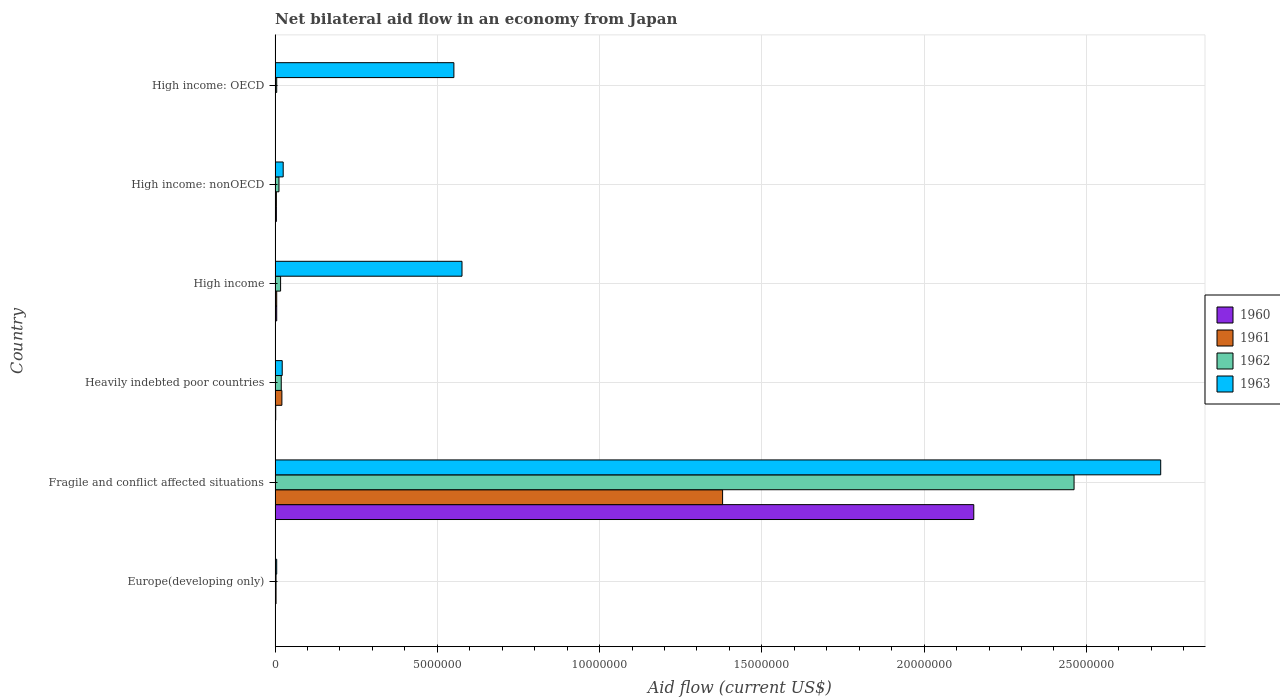How many groups of bars are there?
Provide a short and direct response. 6. Are the number of bars per tick equal to the number of legend labels?
Offer a very short reply. Yes. How many bars are there on the 2nd tick from the bottom?
Ensure brevity in your answer.  4. What is the label of the 6th group of bars from the top?
Provide a succinct answer. Europe(developing only). What is the net bilateral aid flow in 1963 in Fragile and conflict affected situations?
Your response must be concise. 2.73e+07. Across all countries, what is the maximum net bilateral aid flow in 1962?
Your answer should be compact. 2.46e+07. In which country was the net bilateral aid flow in 1963 maximum?
Offer a very short reply. Fragile and conflict affected situations. In which country was the net bilateral aid flow in 1962 minimum?
Keep it short and to the point. Europe(developing only). What is the total net bilateral aid flow in 1962 in the graph?
Offer a terse response. 2.52e+07. What is the difference between the net bilateral aid flow in 1961 in Europe(developing only) and that in High income?
Give a very brief answer. -2.00e+04. What is the difference between the net bilateral aid flow in 1963 in Heavily indebted poor countries and the net bilateral aid flow in 1961 in High income: OECD?
Ensure brevity in your answer.  2.10e+05. What is the average net bilateral aid flow in 1963 per country?
Make the answer very short. 6.51e+06. What is the ratio of the net bilateral aid flow in 1961 in Fragile and conflict affected situations to that in High income?
Offer a very short reply. 275.8. Is the net bilateral aid flow in 1962 in High income less than that in High income: nonOECD?
Offer a terse response. No. Is the difference between the net bilateral aid flow in 1961 in Fragile and conflict affected situations and Heavily indebted poor countries greater than the difference between the net bilateral aid flow in 1963 in Fragile and conflict affected situations and Heavily indebted poor countries?
Ensure brevity in your answer.  No. What is the difference between the highest and the second highest net bilateral aid flow in 1961?
Keep it short and to the point. 1.36e+07. What is the difference between the highest and the lowest net bilateral aid flow in 1961?
Provide a succinct answer. 1.38e+07. Is the sum of the net bilateral aid flow in 1962 in High income and High income: OECD greater than the maximum net bilateral aid flow in 1961 across all countries?
Offer a very short reply. No. What does the 4th bar from the top in High income: OECD represents?
Provide a short and direct response. 1960. What does the 4th bar from the bottom in Heavily indebted poor countries represents?
Make the answer very short. 1963. How many bars are there?
Give a very brief answer. 24. How many countries are there in the graph?
Your answer should be very brief. 6. What is the title of the graph?
Your answer should be very brief. Net bilateral aid flow in an economy from Japan. What is the label or title of the X-axis?
Your answer should be compact. Aid flow (current US$). What is the Aid flow (current US$) in 1961 in Europe(developing only)?
Give a very brief answer. 3.00e+04. What is the Aid flow (current US$) of 1962 in Europe(developing only)?
Ensure brevity in your answer.  3.00e+04. What is the Aid flow (current US$) in 1963 in Europe(developing only)?
Make the answer very short. 5.00e+04. What is the Aid flow (current US$) in 1960 in Fragile and conflict affected situations?
Offer a very short reply. 2.15e+07. What is the Aid flow (current US$) in 1961 in Fragile and conflict affected situations?
Keep it short and to the point. 1.38e+07. What is the Aid flow (current US$) in 1962 in Fragile and conflict affected situations?
Your response must be concise. 2.46e+07. What is the Aid flow (current US$) of 1963 in Fragile and conflict affected situations?
Provide a short and direct response. 2.73e+07. What is the Aid flow (current US$) of 1960 in Heavily indebted poor countries?
Provide a short and direct response. 2.00e+04. What is the Aid flow (current US$) in 1961 in Heavily indebted poor countries?
Ensure brevity in your answer.  2.10e+05. What is the Aid flow (current US$) in 1963 in Heavily indebted poor countries?
Ensure brevity in your answer.  2.20e+05. What is the Aid flow (current US$) in 1962 in High income?
Your answer should be very brief. 1.70e+05. What is the Aid flow (current US$) of 1963 in High income?
Your answer should be compact. 5.76e+06. What is the Aid flow (current US$) of 1962 in High income: nonOECD?
Ensure brevity in your answer.  1.20e+05. What is the Aid flow (current US$) in 1960 in High income: OECD?
Your answer should be compact. 10000. What is the Aid flow (current US$) in 1961 in High income: OECD?
Provide a short and direct response. 10000. What is the Aid flow (current US$) in 1963 in High income: OECD?
Your answer should be very brief. 5.51e+06. Across all countries, what is the maximum Aid flow (current US$) of 1960?
Ensure brevity in your answer.  2.15e+07. Across all countries, what is the maximum Aid flow (current US$) in 1961?
Offer a terse response. 1.38e+07. Across all countries, what is the maximum Aid flow (current US$) in 1962?
Your answer should be very brief. 2.46e+07. Across all countries, what is the maximum Aid flow (current US$) of 1963?
Ensure brevity in your answer.  2.73e+07. Across all countries, what is the minimum Aid flow (current US$) of 1960?
Your answer should be very brief. 10000. Across all countries, what is the minimum Aid flow (current US$) of 1961?
Offer a terse response. 10000. What is the total Aid flow (current US$) in 1960 in the graph?
Your response must be concise. 2.17e+07. What is the total Aid flow (current US$) of 1961 in the graph?
Provide a succinct answer. 1.41e+07. What is the total Aid flow (current US$) of 1962 in the graph?
Ensure brevity in your answer.  2.52e+07. What is the total Aid flow (current US$) in 1963 in the graph?
Keep it short and to the point. 3.91e+07. What is the difference between the Aid flow (current US$) in 1960 in Europe(developing only) and that in Fragile and conflict affected situations?
Offer a terse response. -2.15e+07. What is the difference between the Aid flow (current US$) in 1961 in Europe(developing only) and that in Fragile and conflict affected situations?
Make the answer very short. -1.38e+07. What is the difference between the Aid flow (current US$) in 1962 in Europe(developing only) and that in Fragile and conflict affected situations?
Keep it short and to the point. -2.46e+07. What is the difference between the Aid flow (current US$) of 1963 in Europe(developing only) and that in Fragile and conflict affected situations?
Make the answer very short. -2.72e+07. What is the difference between the Aid flow (current US$) in 1961 in Europe(developing only) and that in Heavily indebted poor countries?
Offer a terse response. -1.80e+05. What is the difference between the Aid flow (current US$) in 1960 in Europe(developing only) and that in High income?
Your answer should be compact. -4.00e+04. What is the difference between the Aid flow (current US$) of 1962 in Europe(developing only) and that in High income?
Provide a short and direct response. -1.40e+05. What is the difference between the Aid flow (current US$) of 1963 in Europe(developing only) and that in High income?
Your answer should be compact. -5.71e+06. What is the difference between the Aid flow (current US$) of 1961 in Europe(developing only) and that in High income: nonOECD?
Provide a short and direct response. -10000. What is the difference between the Aid flow (current US$) of 1963 in Europe(developing only) and that in High income: nonOECD?
Give a very brief answer. -2.00e+05. What is the difference between the Aid flow (current US$) in 1960 in Europe(developing only) and that in High income: OECD?
Provide a short and direct response. 0. What is the difference between the Aid flow (current US$) in 1963 in Europe(developing only) and that in High income: OECD?
Your answer should be compact. -5.46e+06. What is the difference between the Aid flow (current US$) in 1960 in Fragile and conflict affected situations and that in Heavily indebted poor countries?
Ensure brevity in your answer.  2.15e+07. What is the difference between the Aid flow (current US$) of 1961 in Fragile and conflict affected situations and that in Heavily indebted poor countries?
Give a very brief answer. 1.36e+07. What is the difference between the Aid flow (current US$) of 1962 in Fragile and conflict affected situations and that in Heavily indebted poor countries?
Offer a terse response. 2.44e+07. What is the difference between the Aid flow (current US$) in 1963 in Fragile and conflict affected situations and that in Heavily indebted poor countries?
Provide a short and direct response. 2.71e+07. What is the difference between the Aid flow (current US$) of 1960 in Fragile and conflict affected situations and that in High income?
Give a very brief answer. 2.15e+07. What is the difference between the Aid flow (current US$) of 1961 in Fragile and conflict affected situations and that in High income?
Your answer should be compact. 1.37e+07. What is the difference between the Aid flow (current US$) of 1962 in Fragile and conflict affected situations and that in High income?
Provide a succinct answer. 2.44e+07. What is the difference between the Aid flow (current US$) in 1963 in Fragile and conflict affected situations and that in High income?
Keep it short and to the point. 2.15e+07. What is the difference between the Aid flow (current US$) of 1960 in Fragile and conflict affected situations and that in High income: nonOECD?
Your answer should be very brief. 2.15e+07. What is the difference between the Aid flow (current US$) of 1961 in Fragile and conflict affected situations and that in High income: nonOECD?
Keep it short and to the point. 1.38e+07. What is the difference between the Aid flow (current US$) in 1962 in Fragile and conflict affected situations and that in High income: nonOECD?
Offer a terse response. 2.45e+07. What is the difference between the Aid flow (current US$) in 1963 in Fragile and conflict affected situations and that in High income: nonOECD?
Make the answer very short. 2.70e+07. What is the difference between the Aid flow (current US$) of 1960 in Fragile and conflict affected situations and that in High income: OECD?
Your answer should be very brief. 2.15e+07. What is the difference between the Aid flow (current US$) of 1961 in Fragile and conflict affected situations and that in High income: OECD?
Give a very brief answer. 1.38e+07. What is the difference between the Aid flow (current US$) in 1962 in Fragile and conflict affected situations and that in High income: OECD?
Your answer should be very brief. 2.46e+07. What is the difference between the Aid flow (current US$) of 1963 in Fragile and conflict affected situations and that in High income: OECD?
Keep it short and to the point. 2.18e+07. What is the difference between the Aid flow (current US$) of 1960 in Heavily indebted poor countries and that in High income?
Offer a terse response. -3.00e+04. What is the difference between the Aid flow (current US$) in 1961 in Heavily indebted poor countries and that in High income?
Your answer should be compact. 1.60e+05. What is the difference between the Aid flow (current US$) in 1963 in Heavily indebted poor countries and that in High income?
Make the answer very short. -5.54e+06. What is the difference between the Aid flow (current US$) in 1962 in Heavily indebted poor countries and that in High income: nonOECD?
Offer a very short reply. 7.00e+04. What is the difference between the Aid flow (current US$) in 1963 in Heavily indebted poor countries and that in High income: OECD?
Your answer should be very brief. -5.29e+06. What is the difference between the Aid flow (current US$) in 1962 in High income and that in High income: nonOECD?
Your answer should be very brief. 5.00e+04. What is the difference between the Aid flow (current US$) of 1963 in High income and that in High income: nonOECD?
Make the answer very short. 5.51e+06. What is the difference between the Aid flow (current US$) in 1961 in High income and that in High income: OECD?
Provide a succinct answer. 4.00e+04. What is the difference between the Aid flow (current US$) in 1962 in High income and that in High income: OECD?
Your answer should be compact. 1.20e+05. What is the difference between the Aid flow (current US$) of 1963 in High income and that in High income: OECD?
Ensure brevity in your answer.  2.50e+05. What is the difference between the Aid flow (current US$) in 1960 in High income: nonOECD and that in High income: OECD?
Provide a succinct answer. 3.00e+04. What is the difference between the Aid flow (current US$) in 1961 in High income: nonOECD and that in High income: OECD?
Your answer should be very brief. 3.00e+04. What is the difference between the Aid flow (current US$) in 1962 in High income: nonOECD and that in High income: OECD?
Offer a terse response. 7.00e+04. What is the difference between the Aid flow (current US$) in 1963 in High income: nonOECD and that in High income: OECD?
Your answer should be very brief. -5.26e+06. What is the difference between the Aid flow (current US$) of 1960 in Europe(developing only) and the Aid flow (current US$) of 1961 in Fragile and conflict affected situations?
Make the answer very short. -1.38e+07. What is the difference between the Aid flow (current US$) of 1960 in Europe(developing only) and the Aid flow (current US$) of 1962 in Fragile and conflict affected situations?
Give a very brief answer. -2.46e+07. What is the difference between the Aid flow (current US$) in 1960 in Europe(developing only) and the Aid flow (current US$) in 1963 in Fragile and conflict affected situations?
Ensure brevity in your answer.  -2.73e+07. What is the difference between the Aid flow (current US$) in 1961 in Europe(developing only) and the Aid flow (current US$) in 1962 in Fragile and conflict affected situations?
Your answer should be very brief. -2.46e+07. What is the difference between the Aid flow (current US$) in 1961 in Europe(developing only) and the Aid flow (current US$) in 1963 in Fragile and conflict affected situations?
Make the answer very short. -2.73e+07. What is the difference between the Aid flow (current US$) in 1962 in Europe(developing only) and the Aid flow (current US$) in 1963 in Fragile and conflict affected situations?
Ensure brevity in your answer.  -2.73e+07. What is the difference between the Aid flow (current US$) of 1960 in Europe(developing only) and the Aid flow (current US$) of 1961 in Heavily indebted poor countries?
Ensure brevity in your answer.  -2.00e+05. What is the difference between the Aid flow (current US$) of 1960 in Europe(developing only) and the Aid flow (current US$) of 1962 in Heavily indebted poor countries?
Make the answer very short. -1.80e+05. What is the difference between the Aid flow (current US$) in 1960 in Europe(developing only) and the Aid flow (current US$) in 1963 in Heavily indebted poor countries?
Provide a short and direct response. -2.10e+05. What is the difference between the Aid flow (current US$) of 1961 in Europe(developing only) and the Aid flow (current US$) of 1962 in Heavily indebted poor countries?
Ensure brevity in your answer.  -1.60e+05. What is the difference between the Aid flow (current US$) of 1960 in Europe(developing only) and the Aid flow (current US$) of 1961 in High income?
Your answer should be compact. -4.00e+04. What is the difference between the Aid flow (current US$) in 1960 in Europe(developing only) and the Aid flow (current US$) in 1963 in High income?
Keep it short and to the point. -5.75e+06. What is the difference between the Aid flow (current US$) in 1961 in Europe(developing only) and the Aid flow (current US$) in 1962 in High income?
Your answer should be very brief. -1.40e+05. What is the difference between the Aid flow (current US$) in 1961 in Europe(developing only) and the Aid flow (current US$) in 1963 in High income?
Offer a terse response. -5.73e+06. What is the difference between the Aid flow (current US$) in 1962 in Europe(developing only) and the Aid flow (current US$) in 1963 in High income?
Offer a terse response. -5.73e+06. What is the difference between the Aid flow (current US$) of 1960 in Europe(developing only) and the Aid flow (current US$) of 1962 in High income: nonOECD?
Make the answer very short. -1.10e+05. What is the difference between the Aid flow (current US$) of 1960 in Europe(developing only) and the Aid flow (current US$) of 1963 in High income: nonOECD?
Offer a terse response. -2.40e+05. What is the difference between the Aid flow (current US$) in 1961 in Europe(developing only) and the Aid flow (current US$) in 1963 in High income: nonOECD?
Provide a succinct answer. -2.20e+05. What is the difference between the Aid flow (current US$) of 1960 in Europe(developing only) and the Aid flow (current US$) of 1963 in High income: OECD?
Provide a short and direct response. -5.50e+06. What is the difference between the Aid flow (current US$) in 1961 in Europe(developing only) and the Aid flow (current US$) in 1963 in High income: OECD?
Make the answer very short. -5.48e+06. What is the difference between the Aid flow (current US$) in 1962 in Europe(developing only) and the Aid flow (current US$) in 1963 in High income: OECD?
Ensure brevity in your answer.  -5.48e+06. What is the difference between the Aid flow (current US$) of 1960 in Fragile and conflict affected situations and the Aid flow (current US$) of 1961 in Heavily indebted poor countries?
Make the answer very short. 2.13e+07. What is the difference between the Aid flow (current US$) of 1960 in Fragile and conflict affected situations and the Aid flow (current US$) of 1962 in Heavily indebted poor countries?
Your response must be concise. 2.13e+07. What is the difference between the Aid flow (current US$) in 1960 in Fragile and conflict affected situations and the Aid flow (current US$) in 1963 in Heavily indebted poor countries?
Offer a very short reply. 2.13e+07. What is the difference between the Aid flow (current US$) of 1961 in Fragile and conflict affected situations and the Aid flow (current US$) of 1962 in Heavily indebted poor countries?
Make the answer very short. 1.36e+07. What is the difference between the Aid flow (current US$) in 1961 in Fragile and conflict affected situations and the Aid flow (current US$) in 1963 in Heavily indebted poor countries?
Ensure brevity in your answer.  1.36e+07. What is the difference between the Aid flow (current US$) in 1962 in Fragile and conflict affected situations and the Aid flow (current US$) in 1963 in Heavily indebted poor countries?
Make the answer very short. 2.44e+07. What is the difference between the Aid flow (current US$) of 1960 in Fragile and conflict affected situations and the Aid flow (current US$) of 1961 in High income?
Ensure brevity in your answer.  2.15e+07. What is the difference between the Aid flow (current US$) of 1960 in Fragile and conflict affected situations and the Aid flow (current US$) of 1962 in High income?
Offer a terse response. 2.14e+07. What is the difference between the Aid flow (current US$) in 1960 in Fragile and conflict affected situations and the Aid flow (current US$) in 1963 in High income?
Your response must be concise. 1.58e+07. What is the difference between the Aid flow (current US$) of 1961 in Fragile and conflict affected situations and the Aid flow (current US$) of 1962 in High income?
Your answer should be compact. 1.36e+07. What is the difference between the Aid flow (current US$) of 1961 in Fragile and conflict affected situations and the Aid flow (current US$) of 1963 in High income?
Your response must be concise. 8.03e+06. What is the difference between the Aid flow (current US$) of 1962 in Fragile and conflict affected situations and the Aid flow (current US$) of 1963 in High income?
Provide a succinct answer. 1.89e+07. What is the difference between the Aid flow (current US$) in 1960 in Fragile and conflict affected situations and the Aid flow (current US$) in 1961 in High income: nonOECD?
Your answer should be very brief. 2.15e+07. What is the difference between the Aid flow (current US$) in 1960 in Fragile and conflict affected situations and the Aid flow (current US$) in 1962 in High income: nonOECD?
Your answer should be compact. 2.14e+07. What is the difference between the Aid flow (current US$) in 1960 in Fragile and conflict affected situations and the Aid flow (current US$) in 1963 in High income: nonOECD?
Your response must be concise. 2.13e+07. What is the difference between the Aid flow (current US$) of 1961 in Fragile and conflict affected situations and the Aid flow (current US$) of 1962 in High income: nonOECD?
Ensure brevity in your answer.  1.37e+07. What is the difference between the Aid flow (current US$) of 1961 in Fragile and conflict affected situations and the Aid flow (current US$) of 1963 in High income: nonOECD?
Your answer should be compact. 1.35e+07. What is the difference between the Aid flow (current US$) of 1962 in Fragile and conflict affected situations and the Aid flow (current US$) of 1963 in High income: nonOECD?
Provide a succinct answer. 2.44e+07. What is the difference between the Aid flow (current US$) in 1960 in Fragile and conflict affected situations and the Aid flow (current US$) in 1961 in High income: OECD?
Offer a very short reply. 2.15e+07. What is the difference between the Aid flow (current US$) of 1960 in Fragile and conflict affected situations and the Aid flow (current US$) of 1962 in High income: OECD?
Your answer should be compact. 2.15e+07. What is the difference between the Aid flow (current US$) of 1960 in Fragile and conflict affected situations and the Aid flow (current US$) of 1963 in High income: OECD?
Provide a short and direct response. 1.60e+07. What is the difference between the Aid flow (current US$) in 1961 in Fragile and conflict affected situations and the Aid flow (current US$) in 1962 in High income: OECD?
Make the answer very short. 1.37e+07. What is the difference between the Aid flow (current US$) in 1961 in Fragile and conflict affected situations and the Aid flow (current US$) in 1963 in High income: OECD?
Ensure brevity in your answer.  8.28e+06. What is the difference between the Aid flow (current US$) of 1962 in Fragile and conflict affected situations and the Aid flow (current US$) of 1963 in High income: OECD?
Keep it short and to the point. 1.91e+07. What is the difference between the Aid flow (current US$) in 1960 in Heavily indebted poor countries and the Aid flow (current US$) in 1961 in High income?
Provide a succinct answer. -3.00e+04. What is the difference between the Aid flow (current US$) in 1960 in Heavily indebted poor countries and the Aid flow (current US$) in 1962 in High income?
Provide a succinct answer. -1.50e+05. What is the difference between the Aid flow (current US$) of 1960 in Heavily indebted poor countries and the Aid flow (current US$) of 1963 in High income?
Make the answer very short. -5.74e+06. What is the difference between the Aid flow (current US$) of 1961 in Heavily indebted poor countries and the Aid flow (current US$) of 1963 in High income?
Your answer should be compact. -5.55e+06. What is the difference between the Aid flow (current US$) of 1962 in Heavily indebted poor countries and the Aid flow (current US$) of 1963 in High income?
Ensure brevity in your answer.  -5.57e+06. What is the difference between the Aid flow (current US$) in 1960 in Heavily indebted poor countries and the Aid flow (current US$) in 1961 in High income: nonOECD?
Give a very brief answer. -2.00e+04. What is the difference between the Aid flow (current US$) of 1960 in Heavily indebted poor countries and the Aid flow (current US$) of 1962 in High income: nonOECD?
Give a very brief answer. -1.00e+05. What is the difference between the Aid flow (current US$) of 1962 in Heavily indebted poor countries and the Aid flow (current US$) of 1963 in High income: nonOECD?
Provide a succinct answer. -6.00e+04. What is the difference between the Aid flow (current US$) of 1960 in Heavily indebted poor countries and the Aid flow (current US$) of 1963 in High income: OECD?
Keep it short and to the point. -5.49e+06. What is the difference between the Aid flow (current US$) of 1961 in Heavily indebted poor countries and the Aid flow (current US$) of 1963 in High income: OECD?
Offer a terse response. -5.30e+06. What is the difference between the Aid flow (current US$) in 1962 in Heavily indebted poor countries and the Aid flow (current US$) in 1963 in High income: OECD?
Offer a terse response. -5.32e+06. What is the difference between the Aid flow (current US$) in 1960 in High income and the Aid flow (current US$) in 1961 in High income: OECD?
Give a very brief answer. 4.00e+04. What is the difference between the Aid flow (current US$) of 1960 in High income and the Aid flow (current US$) of 1962 in High income: OECD?
Your answer should be compact. 0. What is the difference between the Aid flow (current US$) in 1960 in High income and the Aid flow (current US$) in 1963 in High income: OECD?
Keep it short and to the point. -5.46e+06. What is the difference between the Aid flow (current US$) in 1961 in High income and the Aid flow (current US$) in 1962 in High income: OECD?
Make the answer very short. 0. What is the difference between the Aid flow (current US$) of 1961 in High income and the Aid flow (current US$) of 1963 in High income: OECD?
Keep it short and to the point. -5.46e+06. What is the difference between the Aid flow (current US$) of 1962 in High income and the Aid flow (current US$) of 1963 in High income: OECD?
Provide a short and direct response. -5.34e+06. What is the difference between the Aid flow (current US$) of 1960 in High income: nonOECD and the Aid flow (current US$) of 1961 in High income: OECD?
Ensure brevity in your answer.  3.00e+04. What is the difference between the Aid flow (current US$) in 1960 in High income: nonOECD and the Aid flow (current US$) in 1962 in High income: OECD?
Provide a short and direct response. -10000. What is the difference between the Aid flow (current US$) in 1960 in High income: nonOECD and the Aid flow (current US$) in 1963 in High income: OECD?
Provide a short and direct response. -5.47e+06. What is the difference between the Aid flow (current US$) of 1961 in High income: nonOECD and the Aid flow (current US$) of 1963 in High income: OECD?
Provide a short and direct response. -5.47e+06. What is the difference between the Aid flow (current US$) in 1962 in High income: nonOECD and the Aid flow (current US$) in 1963 in High income: OECD?
Ensure brevity in your answer.  -5.39e+06. What is the average Aid flow (current US$) in 1960 per country?
Offer a very short reply. 3.61e+06. What is the average Aid flow (current US$) in 1961 per country?
Make the answer very short. 2.36e+06. What is the average Aid flow (current US$) of 1962 per country?
Your answer should be very brief. 4.20e+06. What is the average Aid flow (current US$) in 1963 per country?
Give a very brief answer. 6.51e+06. What is the difference between the Aid flow (current US$) in 1960 and Aid flow (current US$) in 1961 in Europe(developing only)?
Give a very brief answer. -2.00e+04. What is the difference between the Aid flow (current US$) in 1961 and Aid flow (current US$) in 1962 in Europe(developing only)?
Offer a very short reply. 0. What is the difference between the Aid flow (current US$) of 1962 and Aid flow (current US$) of 1963 in Europe(developing only)?
Keep it short and to the point. -2.00e+04. What is the difference between the Aid flow (current US$) in 1960 and Aid flow (current US$) in 1961 in Fragile and conflict affected situations?
Your response must be concise. 7.74e+06. What is the difference between the Aid flow (current US$) in 1960 and Aid flow (current US$) in 1962 in Fragile and conflict affected situations?
Provide a short and direct response. -3.09e+06. What is the difference between the Aid flow (current US$) in 1960 and Aid flow (current US$) in 1963 in Fragile and conflict affected situations?
Provide a short and direct response. -5.76e+06. What is the difference between the Aid flow (current US$) of 1961 and Aid flow (current US$) of 1962 in Fragile and conflict affected situations?
Keep it short and to the point. -1.08e+07. What is the difference between the Aid flow (current US$) of 1961 and Aid flow (current US$) of 1963 in Fragile and conflict affected situations?
Offer a very short reply. -1.35e+07. What is the difference between the Aid flow (current US$) in 1962 and Aid flow (current US$) in 1963 in Fragile and conflict affected situations?
Make the answer very short. -2.67e+06. What is the difference between the Aid flow (current US$) in 1960 and Aid flow (current US$) in 1963 in Heavily indebted poor countries?
Offer a very short reply. -2.00e+05. What is the difference between the Aid flow (current US$) of 1960 and Aid flow (current US$) of 1961 in High income?
Your answer should be very brief. 0. What is the difference between the Aid flow (current US$) of 1960 and Aid flow (current US$) of 1962 in High income?
Keep it short and to the point. -1.20e+05. What is the difference between the Aid flow (current US$) of 1960 and Aid flow (current US$) of 1963 in High income?
Provide a succinct answer. -5.71e+06. What is the difference between the Aid flow (current US$) of 1961 and Aid flow (current US$) of 1962 in High income?
Provide a short and direct response. -1.20e+05. What is the difference between the Aid flow (current US$) in 1961 and Aid flow (current US$) in 1963 in High income?
Provide a short and direct response. -5.71e+06. What is the difference between the Aid flow (current US$) in 1962 and Aid flow (current US$) in 1963 in High income?
Give a very brief answer. -5.59e+06. What is the difference between the Aid flow (current US$) in 1960 and Aid flow (current US$) in 1962 in High income: nonOECD?
Make the answer very short. -8.00e+04. What is the difference between the Aid flow (current US$) in 1960 and Aid flow (current US$) in 1963 in High income: nonOECD?
Your answer should be very brief. -2.10e+05. What is the difference between the Aid flow (current US$) of 1961 and Aid flow (current US$) of 1963 in High income: nonOECD?
Keep it short and to the point. -2.10e+05. What is the difference between the Aid flow (current US$) in 1960 and Aid flow (current US$) in 1963 in High income: OECD?
Your answer should be very brief. -5.50e+06. What is the difference between the Aid flow (current US$) in 1961 and Aid flow (current US$) in 1962 in High income: OECD?
Offer a terse response. -4.00e+04. What is the difference between the Aid flow (current US$) of 1961 and Aid flow (current US$) of 1963 in High income: OECD?
Your answer should be compact. -5.50e+06. What is the difference between the Aid flow (current US$) of 1962 and Aid flow (current US$) of 1963 in High income: OECD?
Make the answer very short. -5.46e+06. What is the ratio of the Aid flow (current US$) of 1960 in Europe(developing only) to that in Fragile and conflict affected situations?
Your answer should be compact. 0. What is the ratio of the Aid flow (current US$) of 1961 in Europe(developing only) to that in Fragile and conflict affected situations?
Ensure brevity in your answer.  0. What is the ratio of the Aid flow (current US$) of 1962 in Europe(developing only) to that in Fragile and conflict affected situations?
Your answer should be compact. 0. What is the ratio of the Aid flow (current US$) in 1963 in Europe(developing only) to that in Fragile and conflict affected situations?
Your answer should be compact. 0. What is the ratio of the Aid flow (current US$) of 1961 in Europe(developing only) to that in Heavily indebted poor countries?
Provide a succinct answer. 0.14. What is the ratio of the Aid flow (current US$) in 1962 in Europe(developing only) to that in Heavily indebted poor countries?
Your response must be concise. 0.16. What is the ratio of the Aid flow (current US$) in 1963 in Europe(developing only) to that in Heavily indebted poor countries?
Keep it short and to the point. 0.23. What is the ratio of the Aid flow (current US$) of 1960 in Europe(developing only) to that in High income?
Offer a terse response. 0.2. What is the ratio of the Aid flow (current US$) of 1962 in Europe(developing only) to that in High income?
Provide a short and direct response. 0.18. What is the ratio of the Aid flow (current US$) of 1963 in Europe(developing only) to that in High income?
Provide a short and direct response. 0.01. What is the ratio of the Aid flow (current US$) in 1960 in Europe(developing only) to that in High income: nonOECD?
Your answer should be compact. 0.25. What is the ratio of the Aid flow (current US$) in 1961 in Europe(developing only) to that in High income: nonOECD?
Your response must be concise. 0.75. What is the ratio of the Aid flow (current US$) in 1962 in Europe(developing only) to that in High income: nonOECD?
Offer a very short reply. 0.25. What is the ratio of the Aid flow (current US$) in 1960 in Europe(developing only) to that in High income: OECD?
Your answer should be compact. 1. What is the ratio of the Aid flow (current US$) of 1961 in Europe(developing only) to that in High income: OECD?
Your response must be concise. 3. What is the ratio of the Aid flow (current US$) in 1963 in Europe(developing only) to that in High income: OECD?
Keep it short and to the point. 0.01. What is the ratio of the Aid flow (current US$) in 1960 in Fragile and conflict affected situations to that in Heavily indebted poor countries?
Your answer should be very brief. 1076.5. What is the ratio of the Aid flow (current US$) of 1961 in Fragile and conflict affected situations to that in Heavily indebted poor countries?
Keep it short and to the point. 65.67. What is the ratio of the Aid flow (current US$) in 1962 in Fragile and conflict affected situations to that in Heavily indebted poor countries?
Give a very brief answer. 129.58. What is the ratio of the Aid flow (current US$) of 1963 in Fragile and conflict affected situations to that in Heavily indebted poor countries?
Offer a terse response. 124.05. What is the ratio of the Aid flow (current US$) in 1960 in Fragile and conflict affected situations to that in High income?
Your response must be concise. 430.6. What is the ratio of the Aid flow (current US$) of 1961 in Fragile and conflict affected situations to that in High income?
Your answer should be compact. 275.8. What is the ratio of the Aid flow (current US$) of 1962 in Fragile and conflict affected situations to that in High income?
Ensure brevity in your answer.  144.82. What is the ratio of the Aid flow (current US$) of 1963 in Fragile and conflict affected situations to that in High income?
Your response must be concise. 4.74. What is the ratio of the Aid flow (current US$) of 1960 in Fragile and conflict affected situations to that in High income: nonOECD?
Ensure brevity in your answer.  538.25. What is the ratio of the Aid flow (current US$) in 1961 in Fragile and conflict affected situations to that in High income: nonOECD?
Offer a terse response. 344.75. What is the ratio of the Aid flow (current US$) in 1962 in Fragile and conflict affected situations to that in High income: nonOECD?
Keep it short and to the point. 205.17. What is the ratio of the Aid flow (current US$) of 1963 in Fragile and conflict affected situations to that in High income: nonOECD?
Keep it short and to the point. 109.16. What is the ratio of the Aid flow (current US$) of 1960 in Fragile and conflict affected situations to that in High income: OECD?
Provide a succinct answer. 2153. What is the ratio of the Aid flow (current US$) of 1961 in Fragile and conflict affected situations to that in High income: OECD?
Your answer should be very brief. 1379. What is the ratio of the Aid flow (current US$) in 1962 in Fragile and conflict affected situations to that in High income: OECD?
Your response must be concise. 492.4. What is the ratio of the Aid flow (current US$) of 1963 in Fragile and conflict affected situations to that in High income: OECD?
Provide a short and direct response. 4.95. What is the ratio of the Aid flow (current US$) of 1961 in Heavily indebted poor countries to that in High income?
Keep it short and to the point. 4.2. What is the ratio of the Aid flow (current US$) in 1962 in Heavily indebted poor countries to that in High income?
Keep it short and to the point. 1.12. What is the ratio of the Aid flow (current US$) in 1963 in Heavily indebted poor countries to that in High income?
Provide a short and direct response. 0.04. What is the ratio of the Aid flow (current US$) of 1960 in Heavily indebted poor countries to that in High income: nonOECD?
Offer a terse response. 0.5. What is the ratio of the Aid flow (current US$) of 1961 in Heavily indebted poor countries to that in High income: nonOECD?
Your response must be concise. 5.25. What is the ratio of the Aid flow (current US$) in 1962 in Heavily indebted poor countries to that in High income: nonOECD?
Give a very brief answer. 1.58. What is the ratio of the Aid flow (current US$) of 1960 in Heavily indebted poor countries to that in High income: OECD?
Keep it short and to the point. 2. What is the ratio of the Aid flow (current US$) of 1961 in Heavily indebted poor countries to that in High income: OECD?
Offer a very short reply. 21. What is the ratio of the Aid flow (current US$) of 1963 in Heavily indebted poor countries to that in High income: OECD?
Your answer should be compact. 0.04. What is the ratio of the Aid flow (current US$) in 1960 in High income to that in High income: nonOECD?
Your response must be concise. 1.25. What is the ratio of the Aid flow (current US$) in 1962 in High income to that in High income: nonOECD?
Keep it short and to the point. 1.42. What is the ratio of the Aid flow (current US$) in 1963 in High income to that in High income: nonOECD?
Offer a terse response. 23.04. What is the ratio of the Aid flow (current US$) of 1962 in High income to that in High income: OECD?
Your answer should be very brief. 3.4. What is the ratio of the Aid flow (current US$) of 1963 in High income to that in High income: OECD?
Provide a short and direct response. 1.05. What is the ratio of the Aid flow (current US$) in 1960 in High income: nonOECD to that in High income: OECD?
Ensure brevity in your answer.  4. What is the ratio of the Aid flow (current US$) of 1963 in High income: nonOECD to that in High income: OECD?
Keep it short and to the point. 0.05. What is the difference between the highest and the second highest Aid flow (current US$) in 1960?
Ensure brevity in your answer.  2.15e+07. What is the difference between the highest and the second highest Aid flow (current US$) of 1961?
Your answer should be compact. 1.36e+07. What is the difference between the highest and the second highest Aid flow (current US$) in 1962?
Make the answer very short. 2.44e+07. What is the difference between the highest and the second highest Aid flow (current US$) in 1963?
Give a very brief answer. 2.15e+07. What is the difference between the highest and the lowest Aid flow (current US$) of 1960?
Keep it short and to the point. 2.15e+07. What is the difference between the highest and the lowest Aid flow (current US$) of 1961?
Your answer should be very brief. 1.38e+07. What is the difference between the highest and the lowest Aid flow (current US$) of 1962?
Make the answer very short. 2.46e+07. What is the difference between the highest and the lowest Aid flow (current US$) of 1963?
Offer a very short reply. 2.72e+07. 